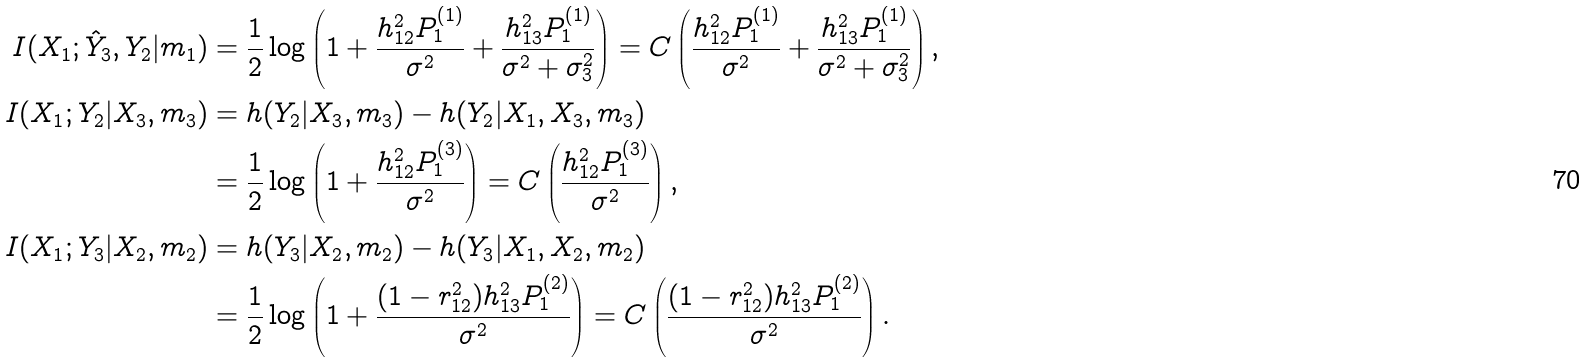<formula> <loc_0><loc_0><loc_500><loc_500>I ( X _ { 1 } ; \hat { Y } _ { 3 } , Y _ { 2 } | m _ { 1 } ) & = \frac { 1 } { 2 } \log \left ( 1 + \frac { h _ { 1 2 } ^ { 2 } P _ { 1 } ^ { ( 1 ) } } { \sigma ^ { 2 } } + \frac { h _ { 1 3 } ^ { 2 } P _ { 1 } ^ { ( 1 ) } } { \sigma ^ { 2 } + \sigma _ { 3 } ^ { 2 } } \right ) = C \left ( \frac { h _ { 1 2 } ^ { 2 } P _ { 1 } ^ { ( 1 ) } } { \sigma ^ { 2 } } + \frac { h _ { 1 3 } ^ { 2 } P _ { 1 } ^ { ( 1 ) } } { \sigma ^ { 2 } + \sigma _ { 3 } ^ { 2 } } \right ) , \\ I ( X _ { 1 } ; Y _ { 2 } | X _ { 3 } , m _ { 3 } ) & = h ( Y _ { 2 } | X _ { 3 } , m _ { 3 } ) - h ( Y _ { 2 } | X _ { 1 } , X _ { 3 } , m _ { 3 } ) \\ & = \frac { 1 } { 2 } \log \left ( 1 + \frac { h _ { 1 2 } ^ { 2 } P _ { 1 } ^ { ( 3 ) } } { \sigma ^ { 2 } } \right ) = C \left ( \frac { h _ { 1 2 } ^ { 2 } P _ { 1 } ^ { ( 3 ) } } { \sigma ^ { 2 } } \right ) , \\ I ( X _ { 1 } ; Y _ { 3 } | X _ { 2 } , m _ { 2 } ) & = h ( Y _ { 3 } | X _ { 2 } , m _ { 2 } ) - h ( Y _ { 3 } | X _ { 1 } , X _ { 2 } , m _ { 2 } ) \\ & = \frac { 1 } { 2 } \log \left ( 1 + \frac { ( 1 - r _ { 1 2 } ^ { 2 } ) h _ { 1 3 } ^ { 2 } P _ { 1 } ^ { ( 2 ) } } { \sigma ^ { 2 } } \right ) = C \left ( \frac { ( 1 - r _ { 1 2 } ^ { 2 } ) h _ { 1 3 } ^ { 2 } P _ { 1 } ^ { ( 2 ) } } { \sigma ^ { 2 } } \right ) .</formula> 